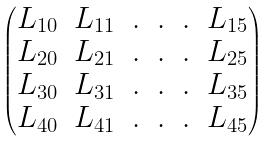Convert formula to latex. <formula><loc_0><loc_0><loc_500><loc_500>\begin{pmatrix} L _ { 1 0 } & L _ { 1 1 } & . & . & . & L _ { 1 5 } \\ L _ { 2 0 } & L _ { 2 1 } & . & . & . & L _ { 2 5 } \\ L _ { 3 0 } & L _ { 3 1 } & . & . & . & L _ { 3 5 } \\ L _ { 4 0 } & L _ { 4 1 } & . & . & . & L _ { 4 5 } \end{pmatrix}</formula> 